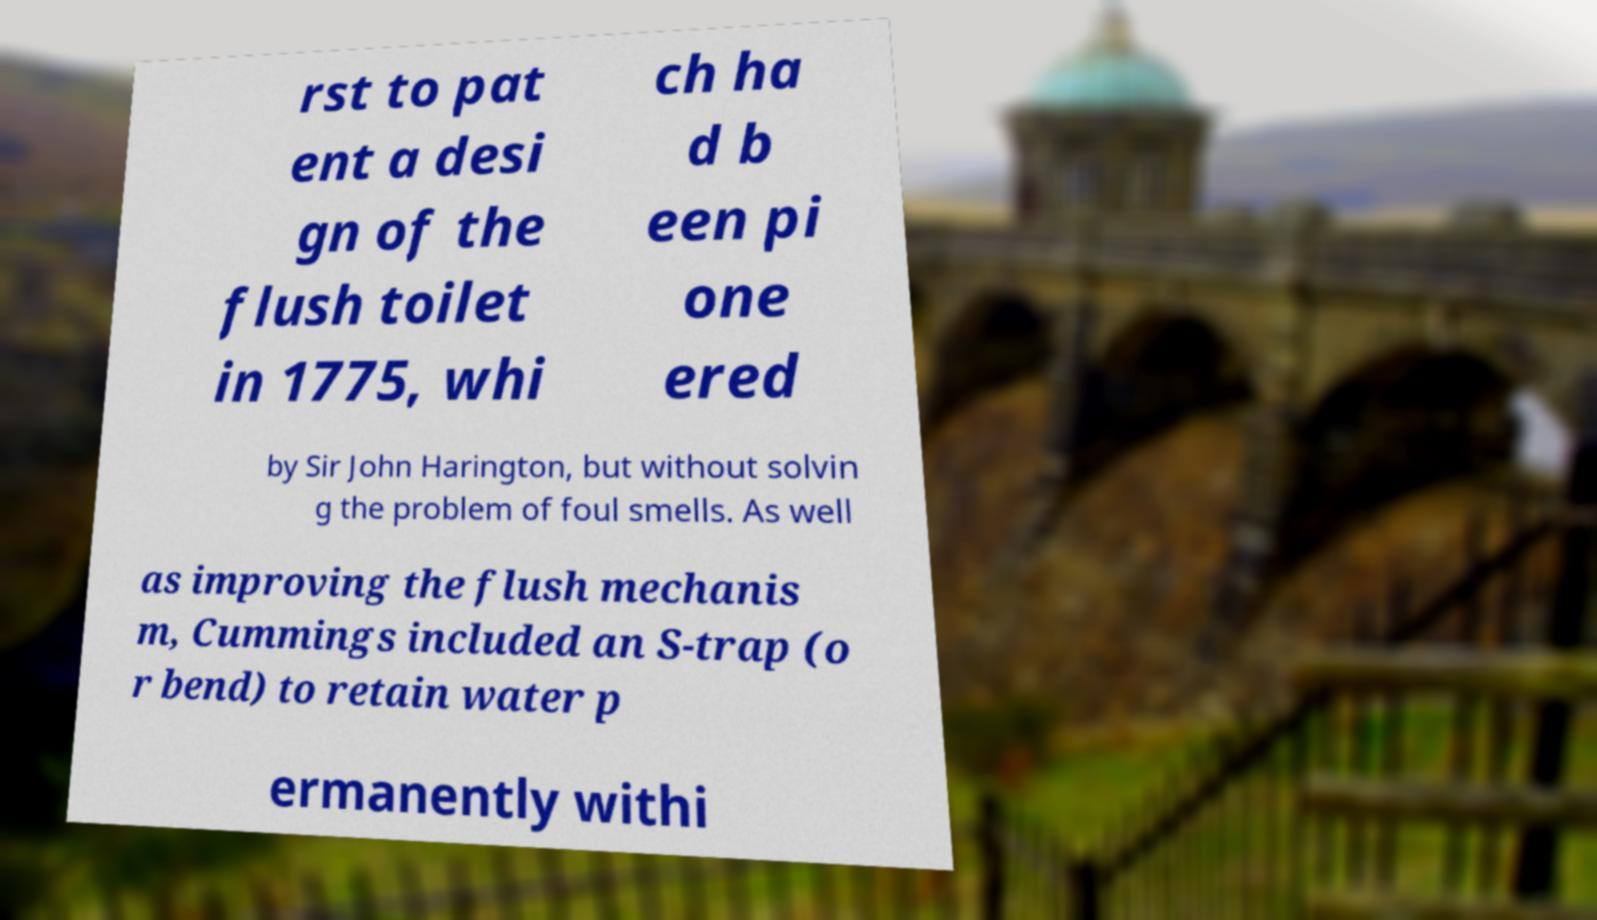For documentation purposes, I need the text within this image transcribed. Could you provide that? rst to pat ent a desi gn of the flush toilet in 1775, whi ch ha d b een pi one ered by Sir John Harington, but without solvin g the problem of foul smells. As well as improving the flush mechanis m, Cummings included an S-trap (o r bend) to retain water p ermanently withi 